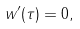<formula> <loc_0><loc_0><loc_500><loc_500>w ^ { \prime } ( \tau ) = 0 ,</formula> 